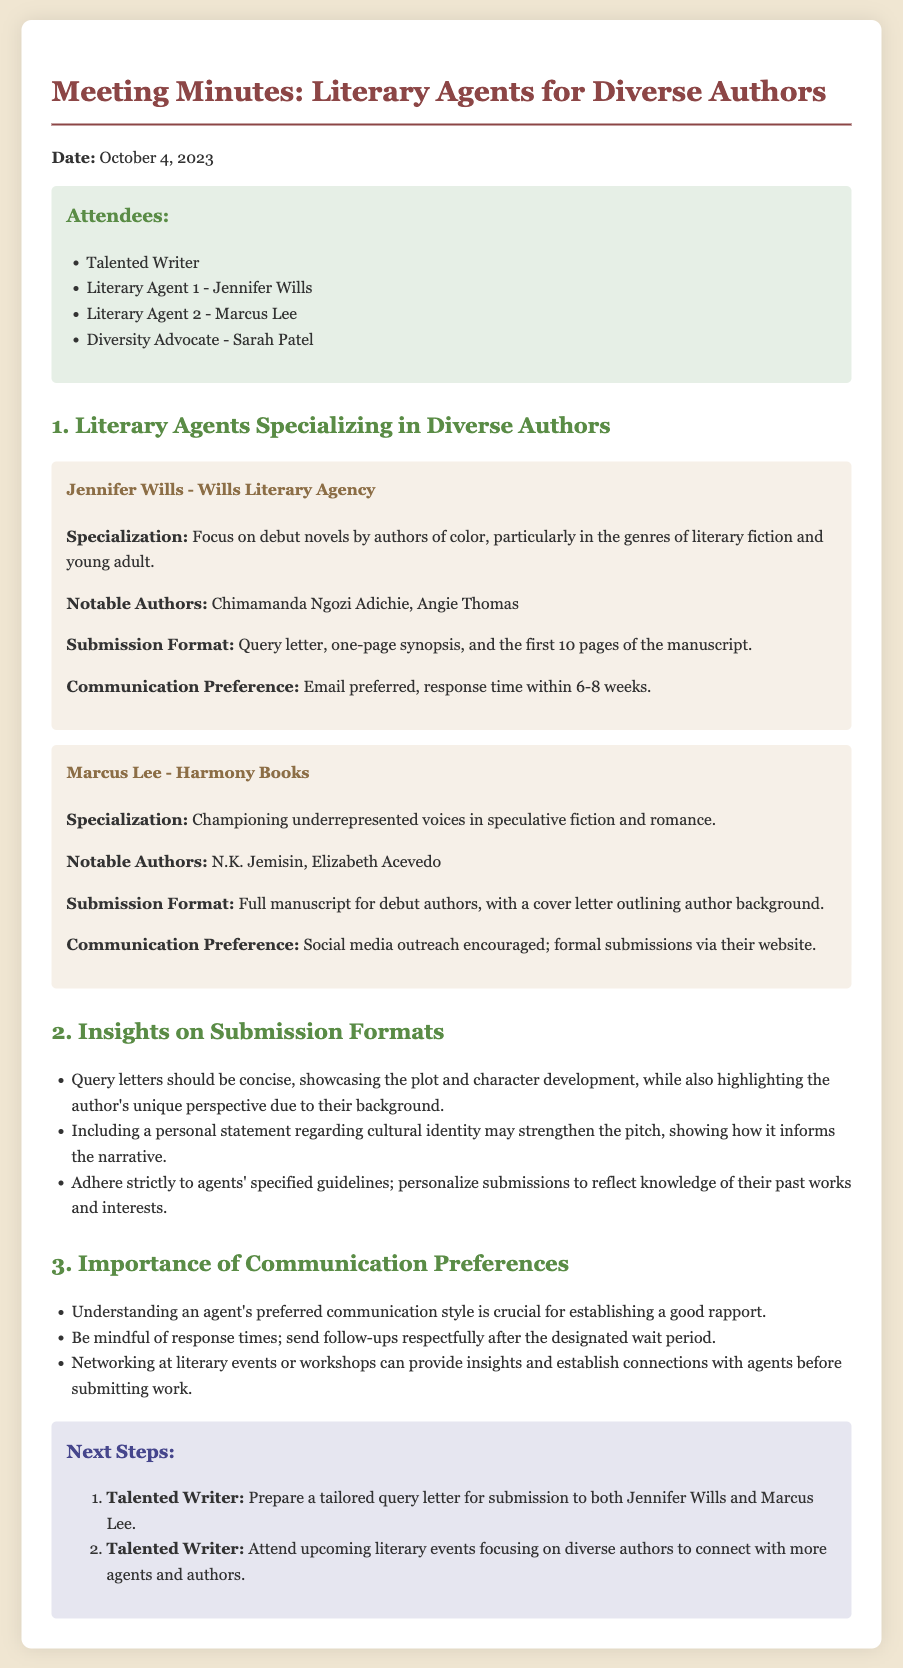What is the date of the meeting? The document states that the meeting took place on October 4, 2023.
Answer: October 4, 2023 Who attended the meeting as a literary agent from Wills Literary Agency? The meeting minutes list Jennifer Wills as the literary agent from Wills Literary Agency.
Answer: Jennifer Wills What is Marcus Lee's specialization? The document specifies that Marcus Lee specializes in championing underrepresented voices in speculative fiction and romance.
Answer: Championing underrepresented voices in speculative fiction and romance How long is the response time preferred by Jennifer Wills? The meeting notes indicate that Jennifer Wills prefers a response time within 6-8 weeks.
Answer: 6-8 weeks What should be included in Marcus Lee's submission format? According to the document, Marcus Lee requires a full manuscript for debut authors with a cover letter outlining the author background.
Answer: Full manuscript with a cover letter outlining author background Why is understanding an agent's preferred communication style important? The document emphasizes that understanding an agent's preferred communication style is crucial for establishing a good rapport.
Answer: Establishing a good rapport What is a recommended step for the Talented Writer after the meeting? The next steps outline that the Talented Writer should prepare a tailored query letter for submission.
Answer: Prepare a tailored query letter What notable authors are associated with Jennifer Wills? The notes mention that Chimamanda Ngozi Adichie and Angie Thomas are notable authors represented by Jennifer Wills.
Answer: Chimamanda Ngozi Adichie, Angie Thomas What should query letters showcase according to the insights on submission formats? The document suggests that query letters should showcase the plot and character development while highlighting the author's unique perspective.
Answer: Showcase the plot and character development 